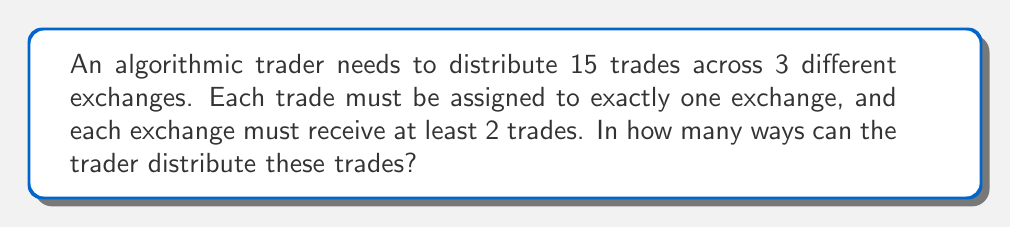Could you help me with this problem? Let's approach this step-by-step using the stars and bars method with restrictions:

1) We have 15 trades (objects) to distribute among 3 exchanges (boxes).

2) Each exchange must receive at least 2 trades. We can account for this by first allocating 2 trades to each exchange:
   15 - (2 * 3) = 9 trades left to distribute

3) Now we need to find the number of ways to distribute 9 trades among 3 exchanges.

4) This is equivalent to finding the number of ways to place 2 dividers among 11 positions (9 trades + 2 dividers = 11 total):

   $$\binom{11}{2}$$

5) We can calculate this using the combination formula:

   $$\binom{11}{2} = \frac{11!}{2!(11-2)!} = \frac{11!}{2!9!}$$

6) Simplifying:
   $$\frac{11 * 10}{2} = 55$$

Therefore, there are 55 ways to distribute the trades.
Answer: 55 